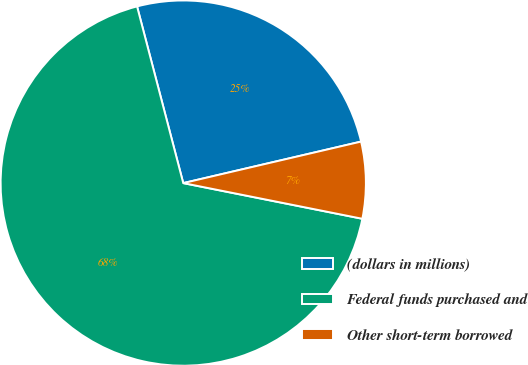Convert chart to OTSL. <chart><loc_0><loc_0><loc_500><loc_500><pie_chart><fcel>(dollars in millions)<fcel>Federal funds purchased and<fcel>Other short-term borrowed<nl><fcel>25.42%<fcel>67.8%<fcel>6.78%<nl></chart> 